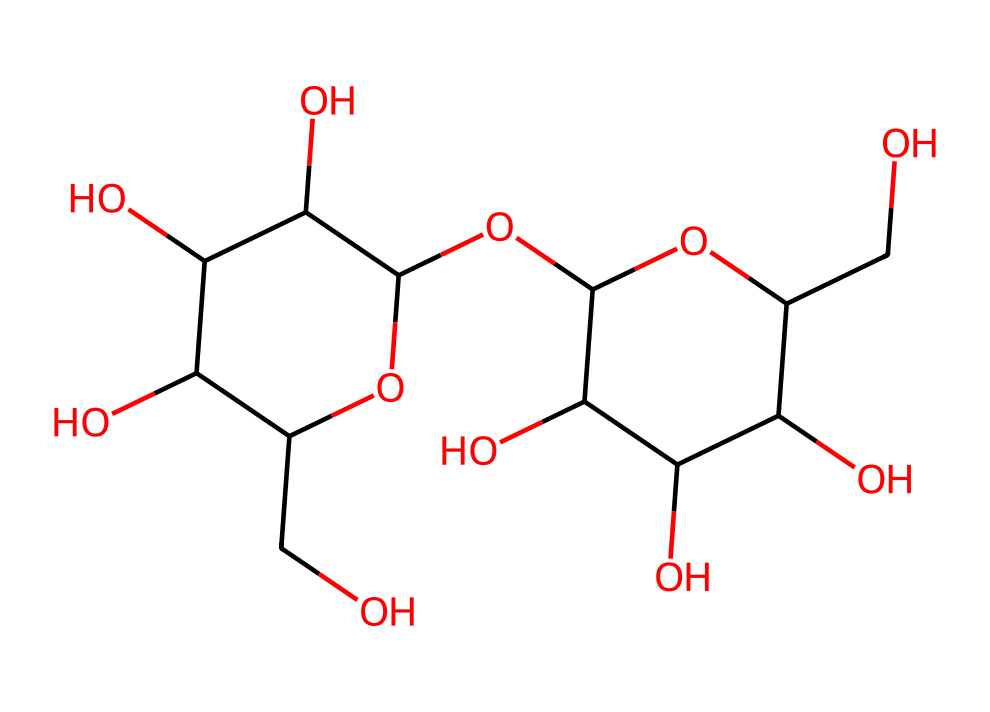What is the molecular formula of lactose? To determine the molecular formula, we can count the number of carbon (C), hydrogen (H), and oxygen (O) atoms present in the chemical structure represented by the SMILES. Observing the structure, we find 12 carbon atoms, 22 hydrogen atoms, and 11 oxygen atoms. Therefore, the molecular formula is C12H22O11.
Answer: C12H22O11 How many rings are present in lactose? By analyzing the structure, we notice that lactose has two cyclic structures, as indicated by the presence of two cyclic portions in the SMILES representation. Each of these forms a ring. Therefore, there are two rings in lactose.
Answer: 2 Is lactose a monosaccharide, disaccharide, or polysaccharide? Lactose consists of two monosaccharide units (glucose and galactose) linked together, making it a disaccharide. This classification is based on its structure and composition.
Answer: disaccharide What is the primary role of lactose in the human body? The primary role of lactose is to provide energy through its breakdown into glucose and galactose, which are essential for various body functions and are particularly important for infants. This shows lactose's role as a source of carbohydrates.
Answer: energy How many hydroxyl (-OH) groups are in lactose? By examining the chemical structure, we can count the hydroxyl groups present. In this case, there are 6 hydroxyl (-OH) groups connected to various carbons in the molecule. The presence of these groups contributes to the molecule's properties, such as solubility.
Answer: 6 